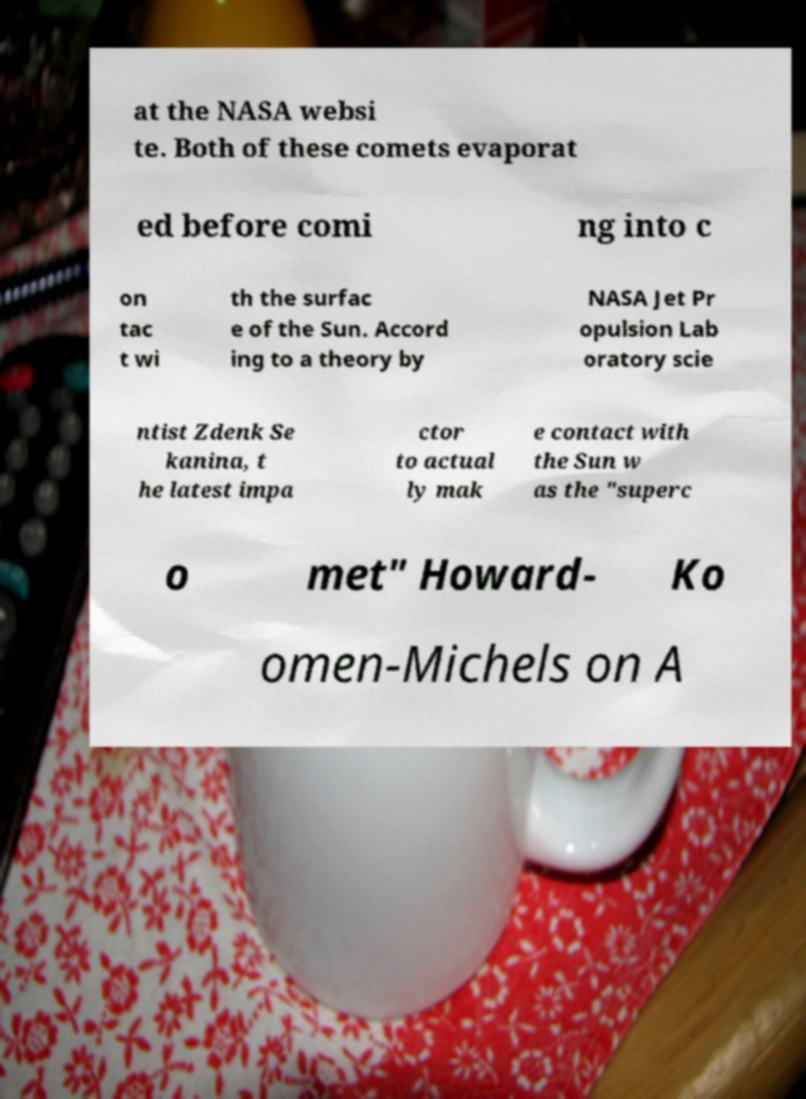I need the written content from this picture converted into text. Can you do that? at the NASA websi te. Both of these comets evaporat ed before comi ng into c on tac t wi th the surfac e of the Sun. Accord ing to a theory by NASA Jet Pr opulsion Lab oratory scie ntist Zdenk Se kanina, t he latest impa ctor to actual ly mak e contact with the Sun w as the "superc o met" Howard- Ko omen-Michels on A 